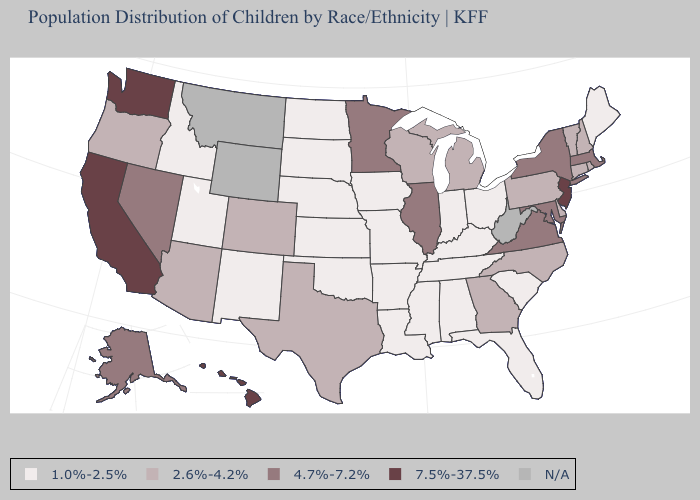Which states have the lowest value in the West?
Write a very short answer. Idaho, New Mexico, Utah. Name the states that have a value in the range 2.6%-4.2%?
Be succinct. Arizona, Colorado, Connecticut, Delaware, Georgia, Michigan, New Hampshire, North Carolina, Oregon, Pennsylvania, Rhode Island, Texas, Vermont, Wisconsin. Is the legend a continuous bar?
Write a very short answer. No. Name the states that have a value in the range 4.7%-7.2%?
Be succinct. Alaska, Illinois, Maryland, Massachusetts, Minnesota, Nevada, New York, Virginia. What is the value of Hawaii?
Be succinct. 7.5%-37.5%. Does New Jersey have the highest value in the USA?
Keep it brief. Yes. What is the value of Michigan?
Answer briefly. 2.6%-4.2%. Does Virginia have the lowest value in the USA?
Give a very brief answer. No. Name the states that have a value in the range 2.6%-4.2%?
Give a very brief answer. Arizona, Colorado, Connecticut, Delaware, Georgia, Michigan, New Hampshire, North Carolina, Oregon, Pennsylvania, Rhode Island, Texas, Vermont, Wisconsin. Which states have the lowest value in the MidWest?
Write a very short answer. Indiana, Iowa, Kansas, Missouri, Nebraska, North Dakota, Ohio, South Dakota. Name the states that have a value in the range 4.7%-7.2%?
Be succinct. Alaska, Illinois, Maryland, Massachusetts, Minnesota, Nevada, New York, Virginia. Which states have the lowest value in the USA?
Write a very short answer. Alabama, Arkansas, Florida, Idaho, Indiana, Iowa, Kansas, Kentucky, Louisiana, Maine, Mississippi, Missouri, Nebraska, New Mexico, North Dakota, Ohio, Oklahoma, South Carolina, South Dakota, Tennessee, Utah. What is the value of Massachusetts?
Concise answer only. 4.7%-7.2%. Is the legend a continuous bar?
Short answer required. No. 